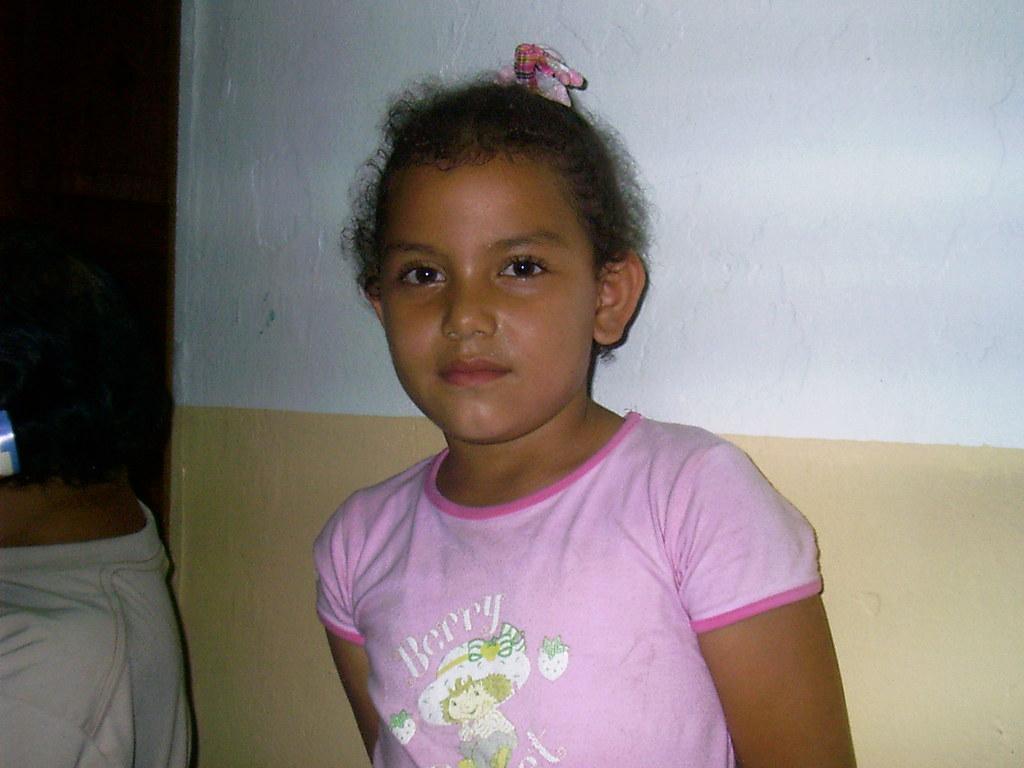How would you summarize this image in a sentence or two? In this image there are two kids. In the background there is a wall. 